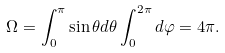<formula> <loc_0><loc_0><loc_500><loc_500>\Omega = \int _ { 0 } ^ { \pi } \sin \theta d \theta \int _ { 0 } ^ { 2 \pi } d \varphi = 4 \pi .</formula> 